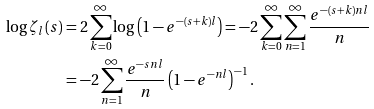<formula> <loc_0><loc_0><loc_500><loc_500>\log \zeta _ { l } ( s ) & = 2 \sum _ { k = 0 } ^ { \infty } \log \left ( 1 - e ^ { - ( s + k ) l } \right ) = - 2 \sum _ { k = 0 } ^ { \infty } \sum _ { n = 1 } ^ { \infty } \frac { e ^ { - ( s + k ) n l } } n \\ & = - 2 \sum _ { n = 1 } ^ { \infty } \frac { e ^ { - s n l } } n \left ( 1 - e ^ { - n l } \right ) ^ { - 1 } .</formula> 